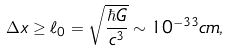Convert formula to latex. <formula><loc_0><loc_0><loc_500><loc_500>\Delta x \geq \ell _ { 0 } = \sqrt { \frac { \hbar { G } } { c ^ { 3 } } } \sim 1 0 ^ { - 3 3 } c m ,</formula> 